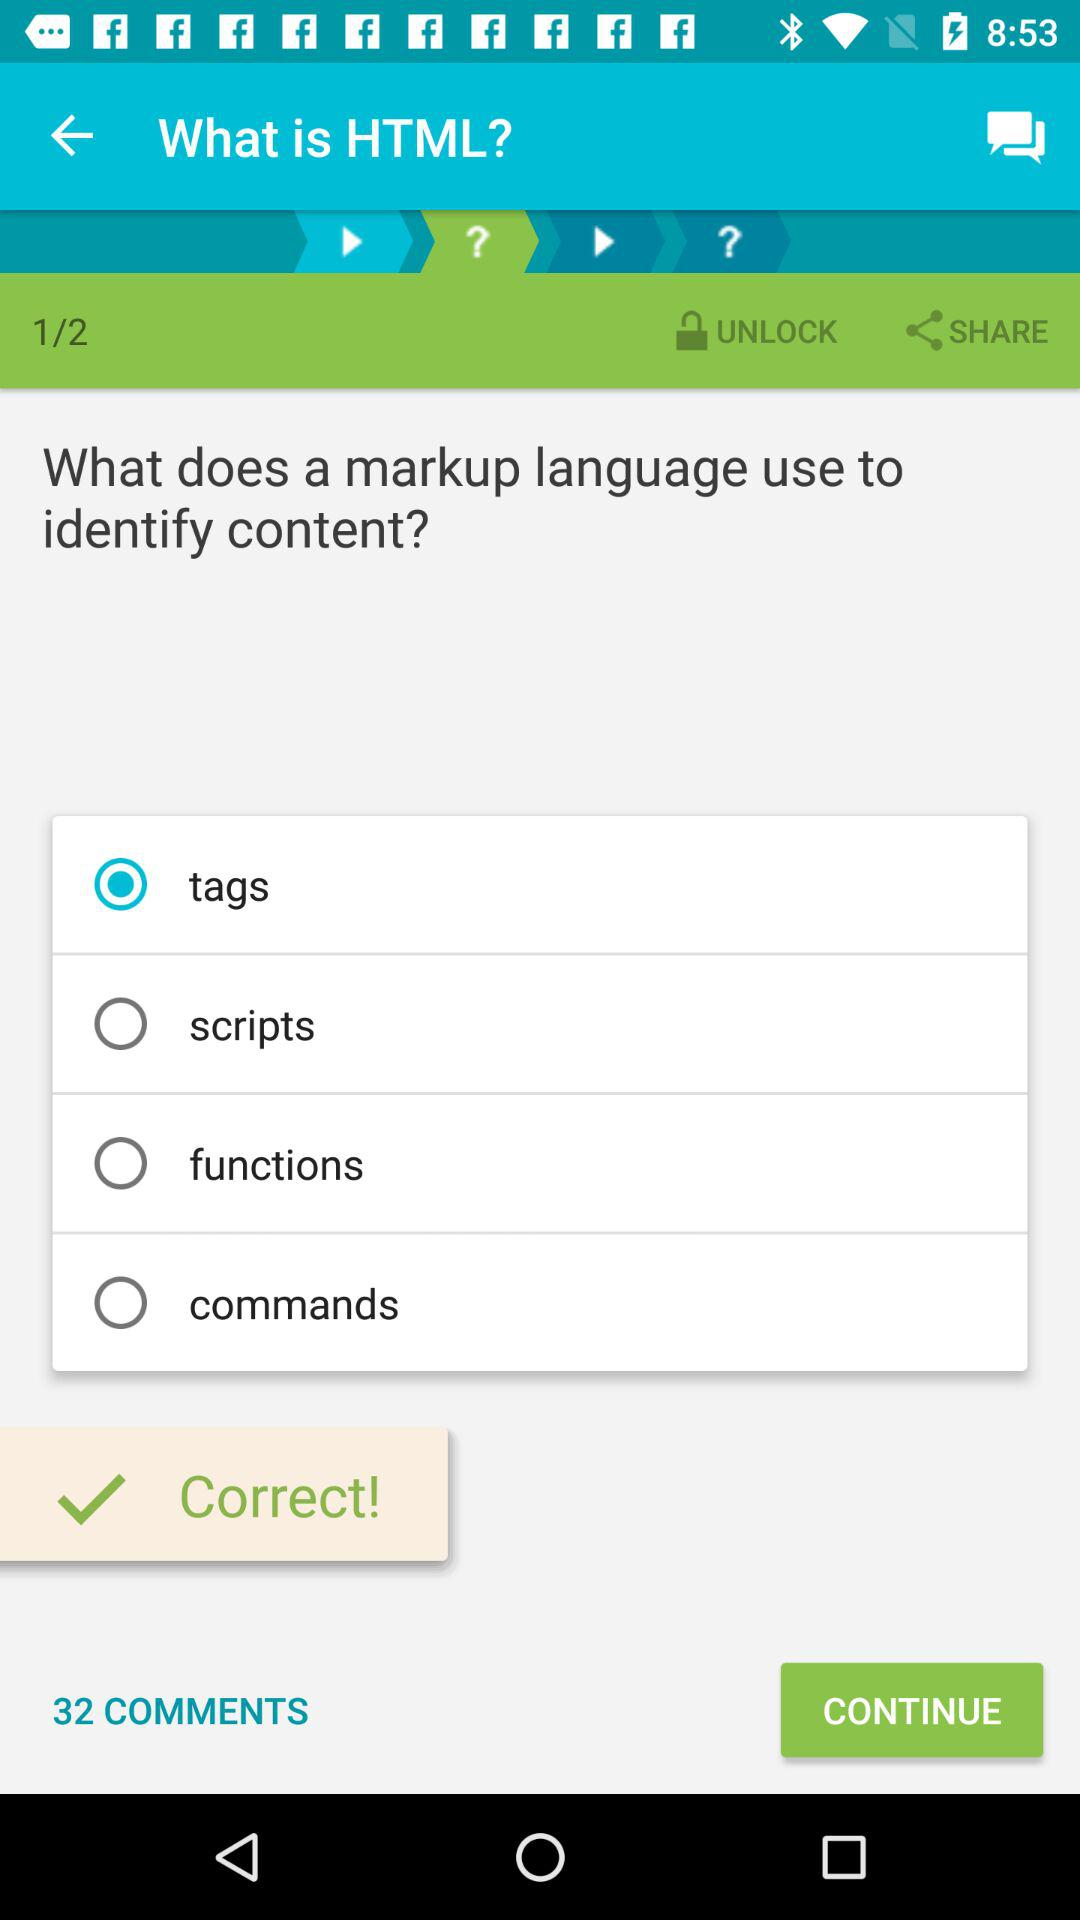Which question are we on? You are on question 1. 